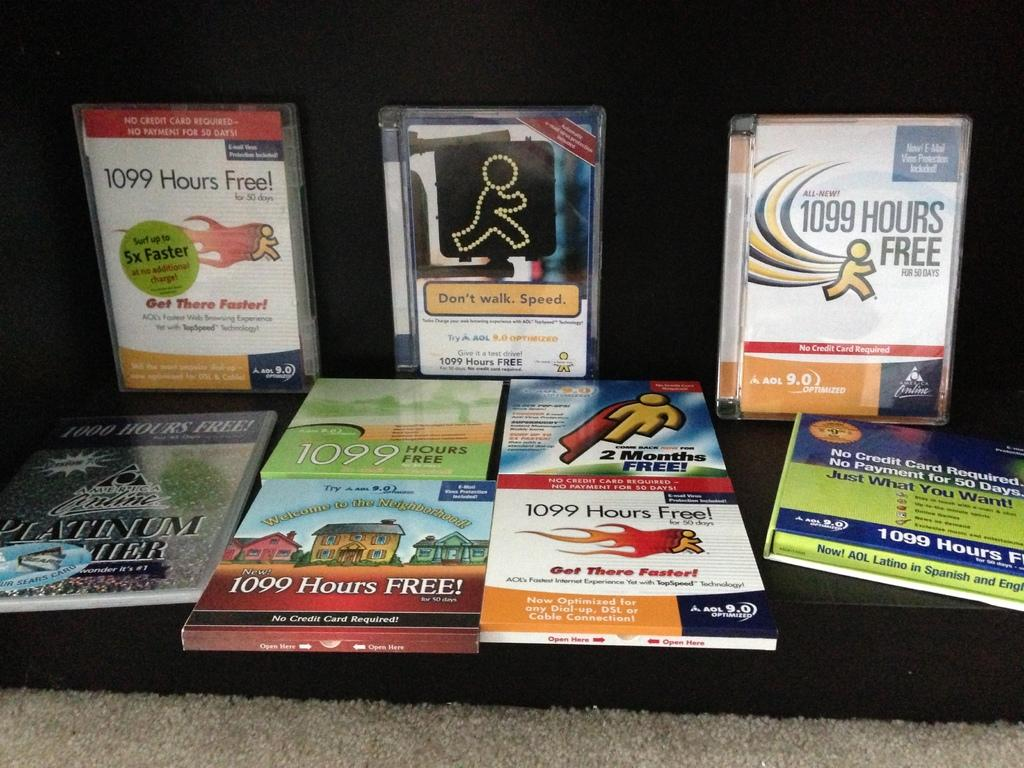<image>
Share a concise interpretation of the image provided. AOL disks on a table advertising 1099 hours free. 